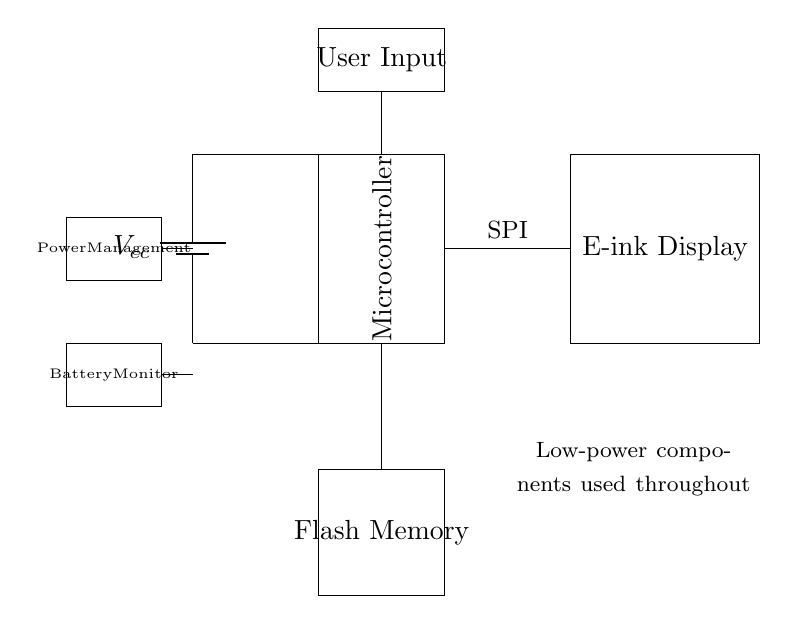What is the main power supply for the circuit? The main power supply is a battery, indicated by the "Vcc" label, which provides the necessary voltage for the circuit operation.
Answer: battery Which component manages power in the circuit? The component that manages power in the circuit is labeled as "Power Management," which is responsible for regulating the power supply to other components.
Answer: Power Management What is the communication protocol used between the microcontroller and the e-ink display? The communication protocol is labeled "SPI," which stands for Serial Peripheral Interface, a common protocol for communication between microcontrollers and peripheral devices.
Answer: SPI How many main functional blocks are visible in the circuit? There are four main functional blocks visible in the circuit: the microcontroller, the e-ink display, flash memory, and user input.
Answer: four What is the purpose of the flash memory in this circuit? The flash memory is used for storing data or firmware necessary for the operation of the electronic dictionary, allowing for non-volatile storage.
Answer: data storage What is indicated by the note about low-power components in the circuit? The note indicates that the components used throughout the circuit are designed to consume minimal power, which is essential for maintaining an efficient low-power device.
Answer: low-power components What function does the battery monitor serve in this circuit? The battery monitor is responsible for monitoring the voltage level of the battery, ensuring that the power supply remains within operational limits for proper functioning of the circuit.
Answer: battery monitoring 